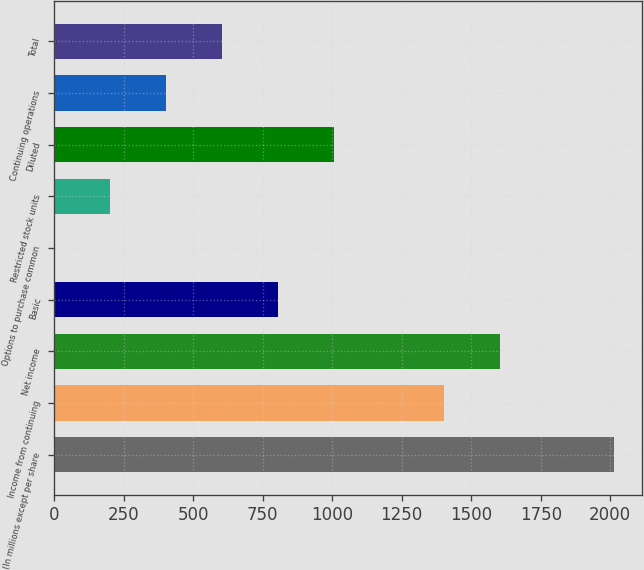Convert chart to OTSL. <chart><loc_0><loc_0><loc_500><loc_500><bar_chart><fcel>(In millions except per share<fcel>Income from continuing<fcel>Net income<fcel>Basic<fcel>Options to purchase common<fcel>Restricted stock units<fcel>Diluted<fcel>Continuing operations<fcel>Total<nl><fcel>2012<fcel>1403<fcel>1604<fcel>806<fcel>2<fcel>203<fcel>1007<fcel>404<fcel>605<nl></chart> 